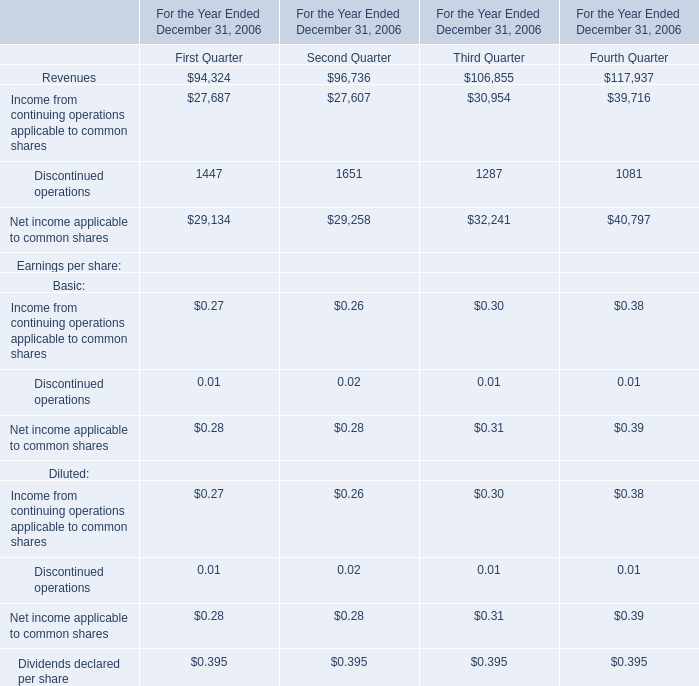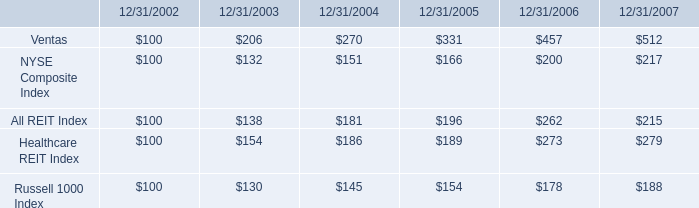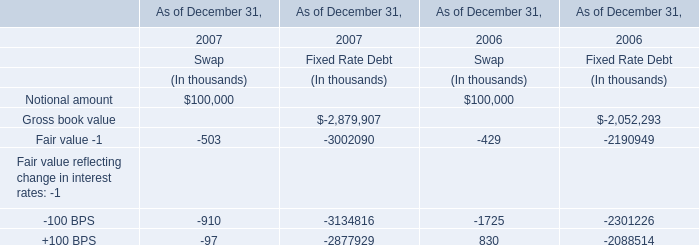what was the growth rate of the ventas stock as of 12/31/2003 
Computations: ((206 - 100) / 100)
Answer: 1.06. 